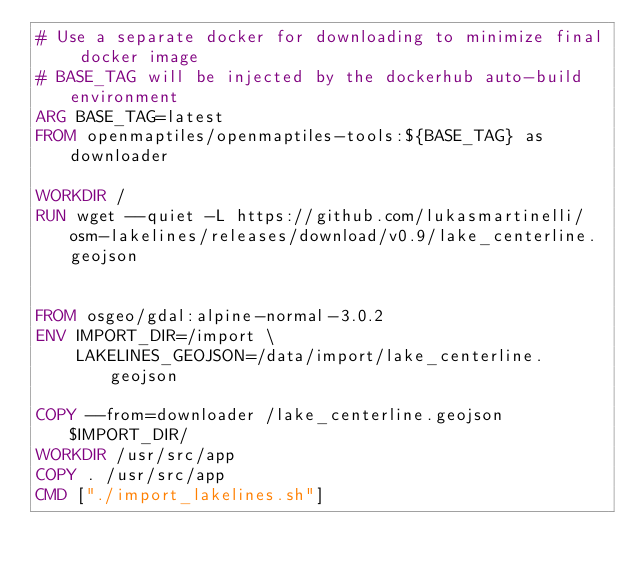Convert code to text. <code><loc_0><loc_0><loc_500><loc_500><_Dockerfile_># Use a separate docker for downloading to minimize final docker image
# BASE_TAG will be injected by the dockerhub auto-build environment
ARG BASE_TAG=latest
FROM openmaptiles/openmaptiles-tools:${BASE_TAG} as downloader

WORKDIR /
RUN wget --quiet -L https://github.com/lukasmartinelli/osm-lakelines/releases/download/v0.9/lake_centerline.geojson


FROM osgeo/gdal:alpine-normal-3.0.2
ENV IMPORT_DIR=/import \
    LAKELINES_GEOJSON=/data/import/lake_centerline.geojson

COPY --from=downloader /lake_centerline.geojson $IMPORT_DIR/
WORKDIR /usr/src/app
COPY . /usr/src/app
CMD ["./import_lakelines.sh"]
</code> 